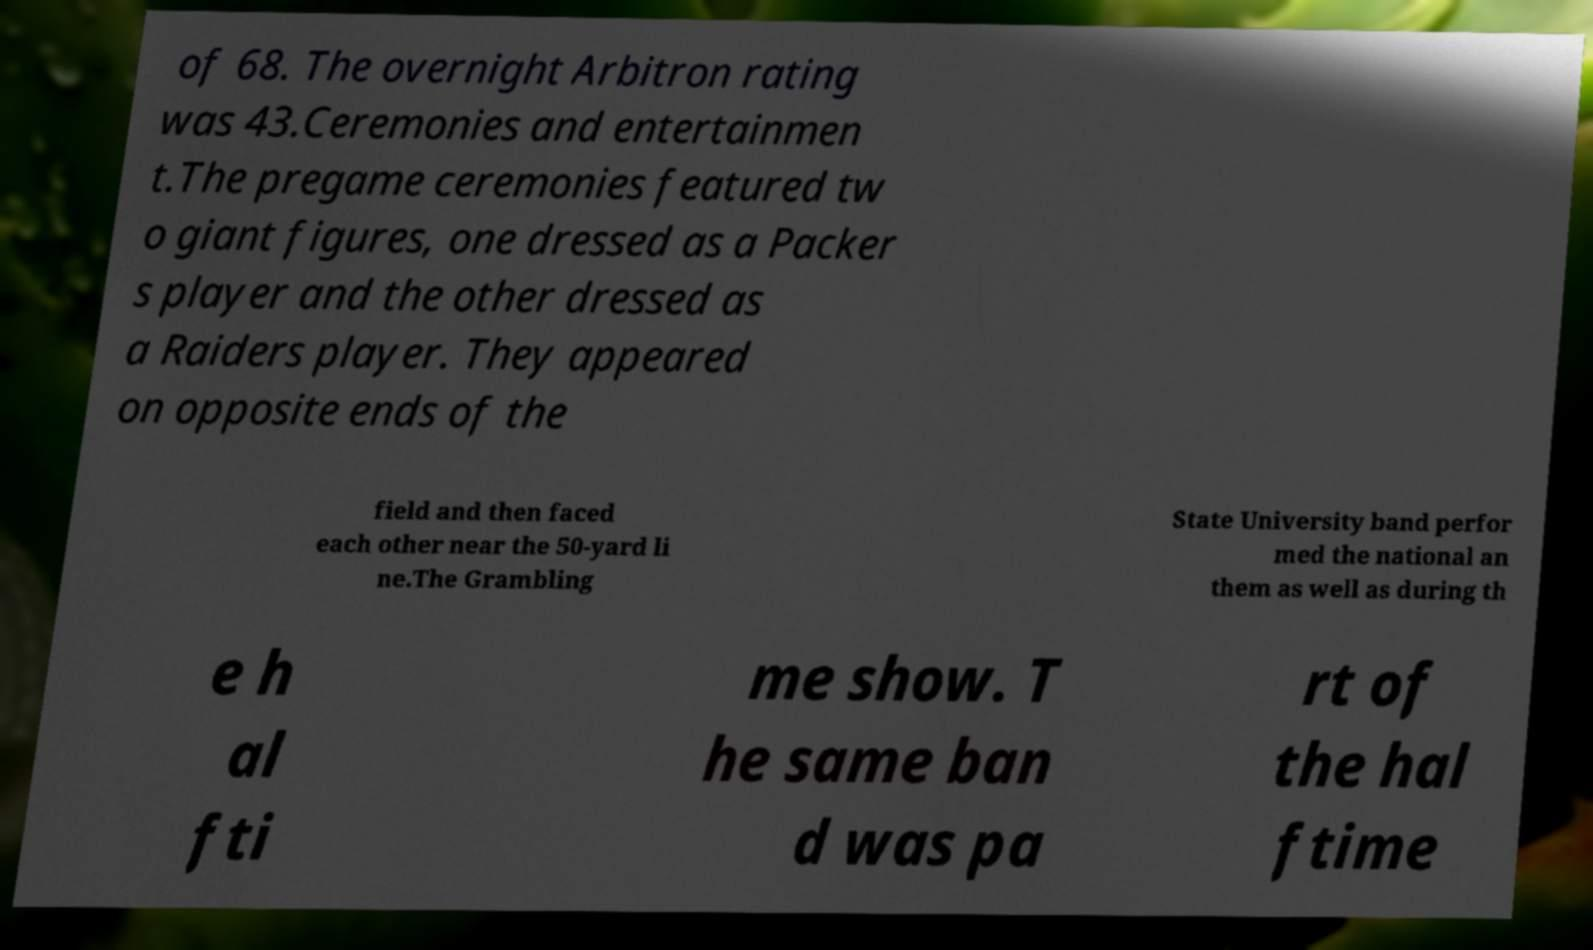Could you assist in decoding the text presented in this image and type it out clearly? of 68. The overnight Arbitron rating was 43.Ceremonies and entertainmen t.The pregame ceremonies featured tw o giant figures, one dressed as a Packer s player and the other dressed as a Raiders player. They appeared on opposite ends of the field and then faced each other near the 50-yard li ne.The Grambling State University band perfor med the national an them as well as during th e h al fti me show. T he same ban d was pa rt of the hal ftime 